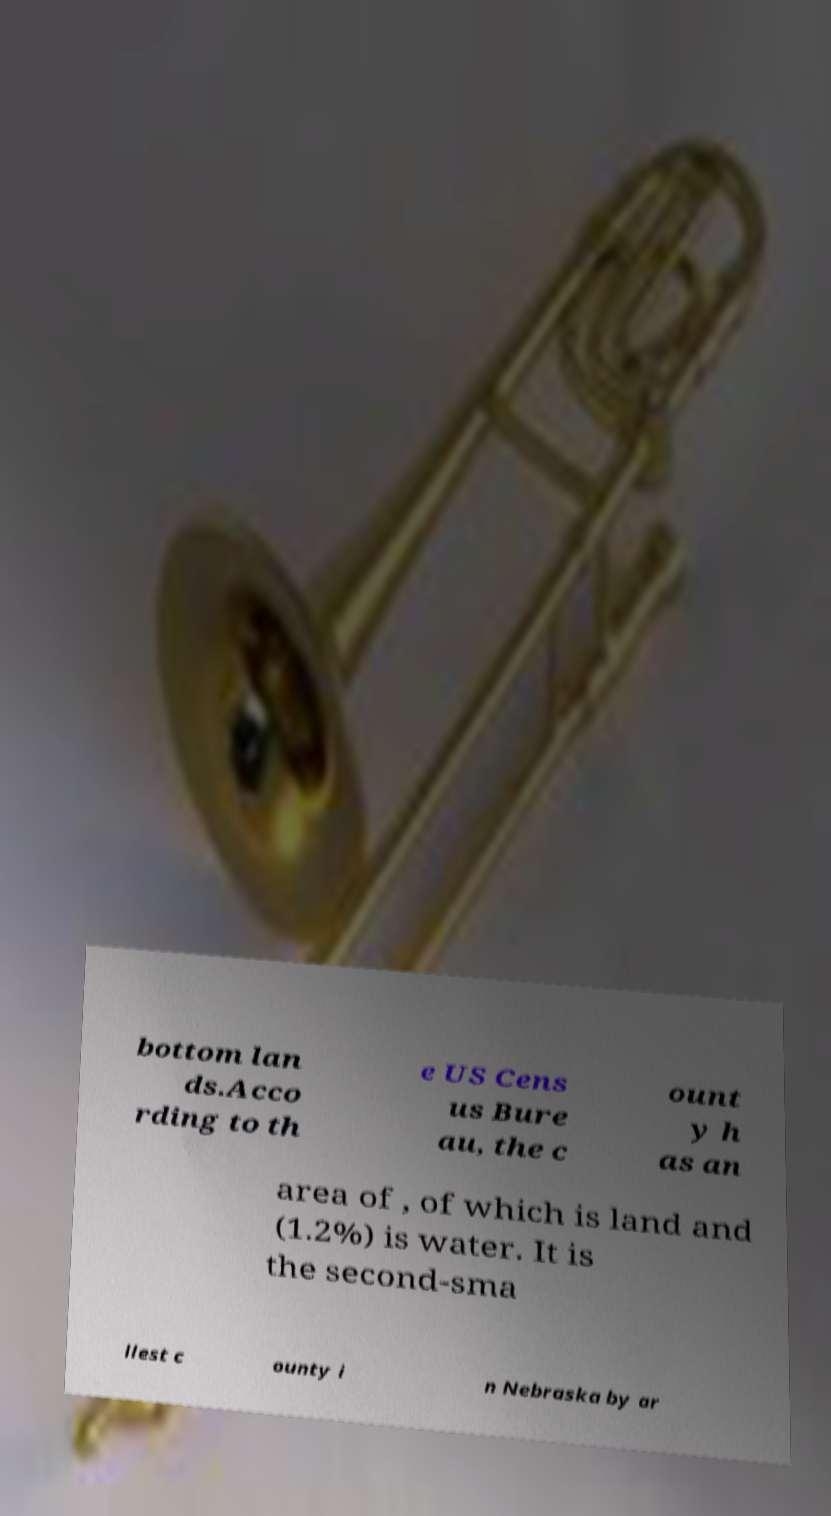There's text embedded in this image that I need extracted. Can you transcribe it verbatim? bottom lan ds.Acco rding to th e US Cens us Bure au, the c ount y h as an area of , of which is land and (1.2%) is water. It is the second-sma llest c ounty i n Nebraska by ar 